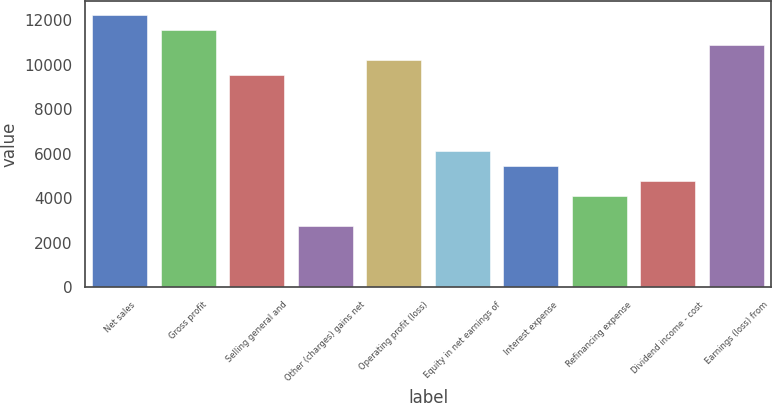Convert chart to OTSL. <chart><loc_0><loc_0><loc_500><loc_500><bar_chart><fcel>Net sales<fcel>Gross profit<fcel>Selling general and<fcel>Other (charges) gains net<fcel>Operating profit (loss)<fcel>Equity in net earnings of<fcel>Interest expense<fcel>Refinancing expense<fcel>Dividend income - cost<fcel>Earnings (loss) from<nl><fcel>12238<fcel>11558.5<fcel>9520<fcel>2725<fcel>10199.5<fcel>6122.5<fcel>5443<fcel>4084<fcel>4763.5<fcel>10879<nl></chart> 